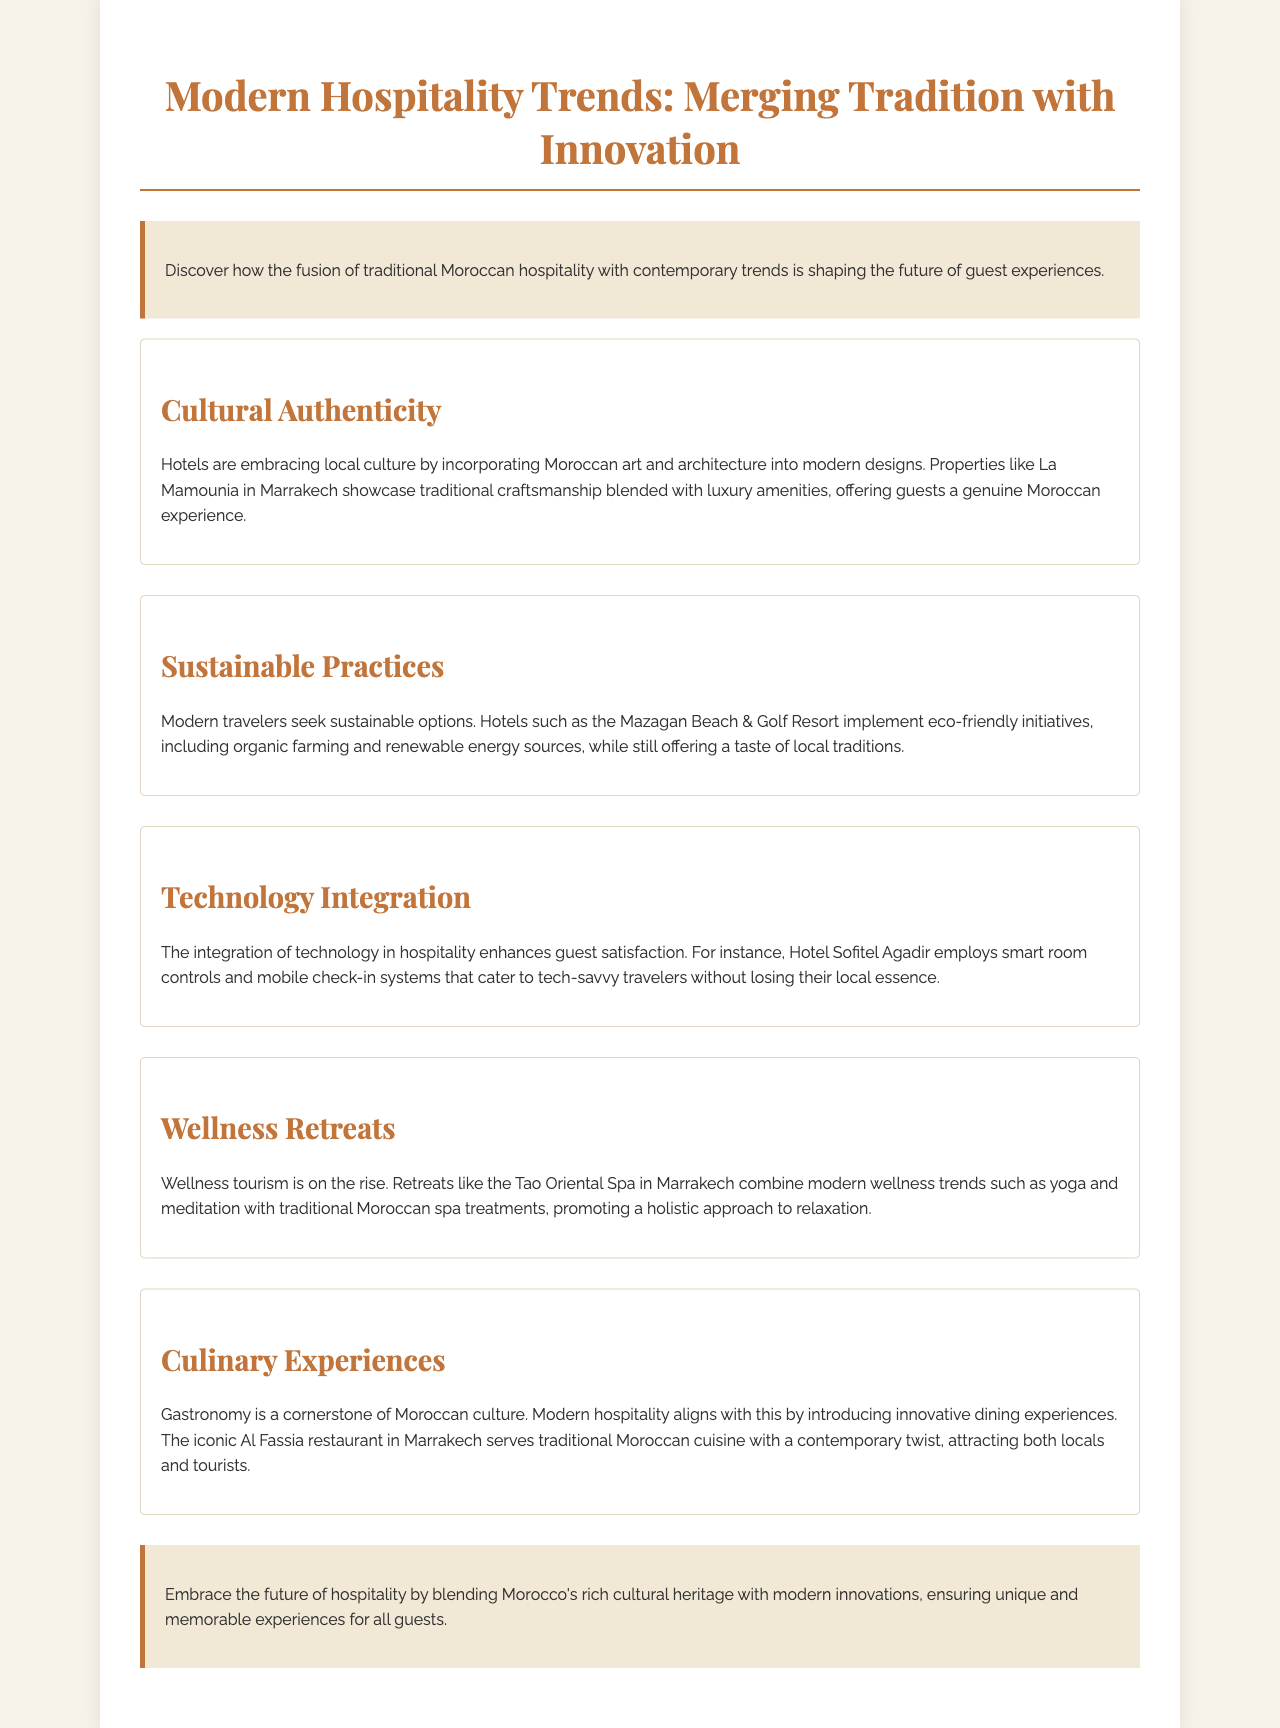what is the title of the document? The title of the document is mentioned at the top and highlights the theme of the brochure.
Answer: Modern Hospitality Trends: Merging Tradition with Innovation what hotel is mentioned as an example of cultural authenticity? The hotel highlighted in the section on cultural authenticity exemplifies the blend of tradition and luxury.
Answer: La Mamounia what type of eco-friendly initiatives does the Mazagan Beach & Golf Resort implement? The document specifies the efforts made by the Mazagan Beach & Golf Resort regarding sustainability.
Answer: Organic farming and renewable energy sources which hotel's approach includes smart room controls? The hotel described in the technology integration section uses smart technology to enhance guest experience.
Answer: Hotel Sofitel Agadir what wellness trend is combined with traditional Moroccan spa treatments? The section on wellness retreats discusses the rising trend that hotels are adopting to attract health-conscious guests.
Answer: Yoga and meditation how does Al Fassia restaurant innovate its dining experience? The culinary experiences section highlights how this restaurant interprets Moroccan cuisine for modern diners.
Answer: Contemporary twist 